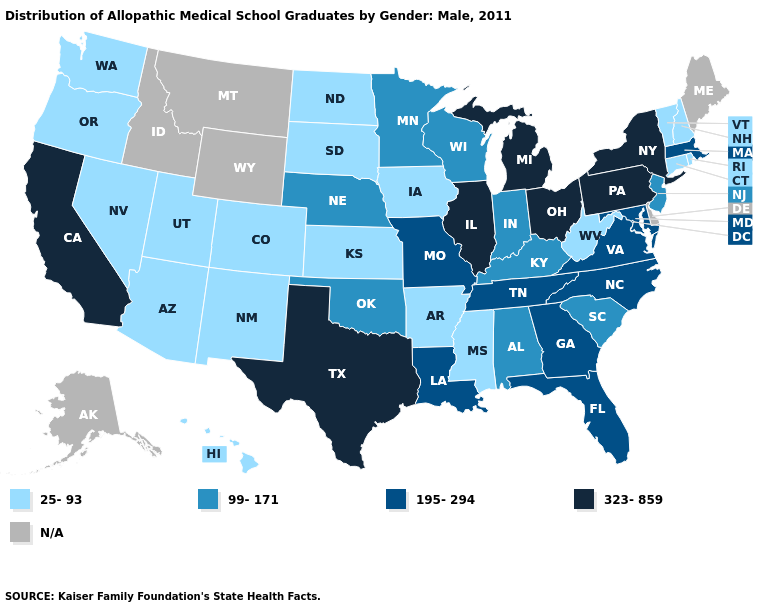What is the lowest value in states that border New York?
Be succinct. 25-93. Which states have the highest value in the USA?
Answer briefly. California, Illinois, Michigan, New York, Ohio, Pennsylvania, Texas. What is the highest value in the South ?
Answer briefly. 323-859. What is the value of Washington?
Short answer required. 25-93. How many symbols are there in the legend?
Be succinct. 5. Does the map have missing data?
Be succinct. Yes. Name the states that have a value in the range 25-93?
Short answer required. Arizona, Arkansas, Colorado, Connecticut, Hawaii, Iowa, Kansas, Mississippi, Nevada, New Hampshire, New Mexico, North Dakota, Oregon, Rhode Island, South Dakota, Utah, Vermont, Washington, West Virginia. Does the map have missing data?
Answer briefly. Yes. What is the value of Utah?
Give a very brief answer. 25-93. Name the states that have a value in the range 99-171?
Concise answer only. Alabama, Indiana, Kentucky, Minnesota, Nebraska, New Jersey, Oklahoma, South Carolina, Wisconsin. What is the highest value in the West ?
Keep it brief. 323-859. How many symbols are there in the legend?
Short answer required. 5. Which states have the lowest value in the MidWest?
Be succinct. Iowa, Kansas, North Dakota, South Dakota. 